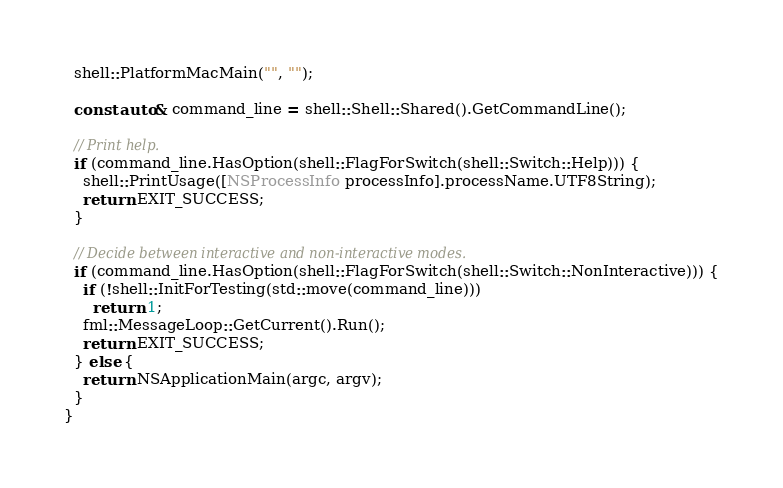Convert code to text. <code><loc_0><loc_0><loc_500><loc_500><_ObjectiveC_>
  shell::PlatformMacMain("", "");

  const auto& command_line = shell::Shell::Shared().GetCommandLine();

  // Print help.
  if (command_line.HasOption(shell::FlagForSwitch(shell::Switch::Help))) {
    shell::PrintUsage([NSProcessInfo processInfo].processName.UTF8String);
    return EXIT_SUCCESS;
  }

  // Decide between interactive and non-interactive modes.
  if (command_line.HasOption(shell::FlagForSwitch(shell::Switch::NonInteractive))) {
    if (!shell::InitForTesting(std::move(command_line)))
      return 1;
    fml::MessageLoop::GetCurrent().Run();
    return EXIT_SUCCESS;
  } else {
    return NSApplicationMain(argc, argv);
  }
}
</code> 